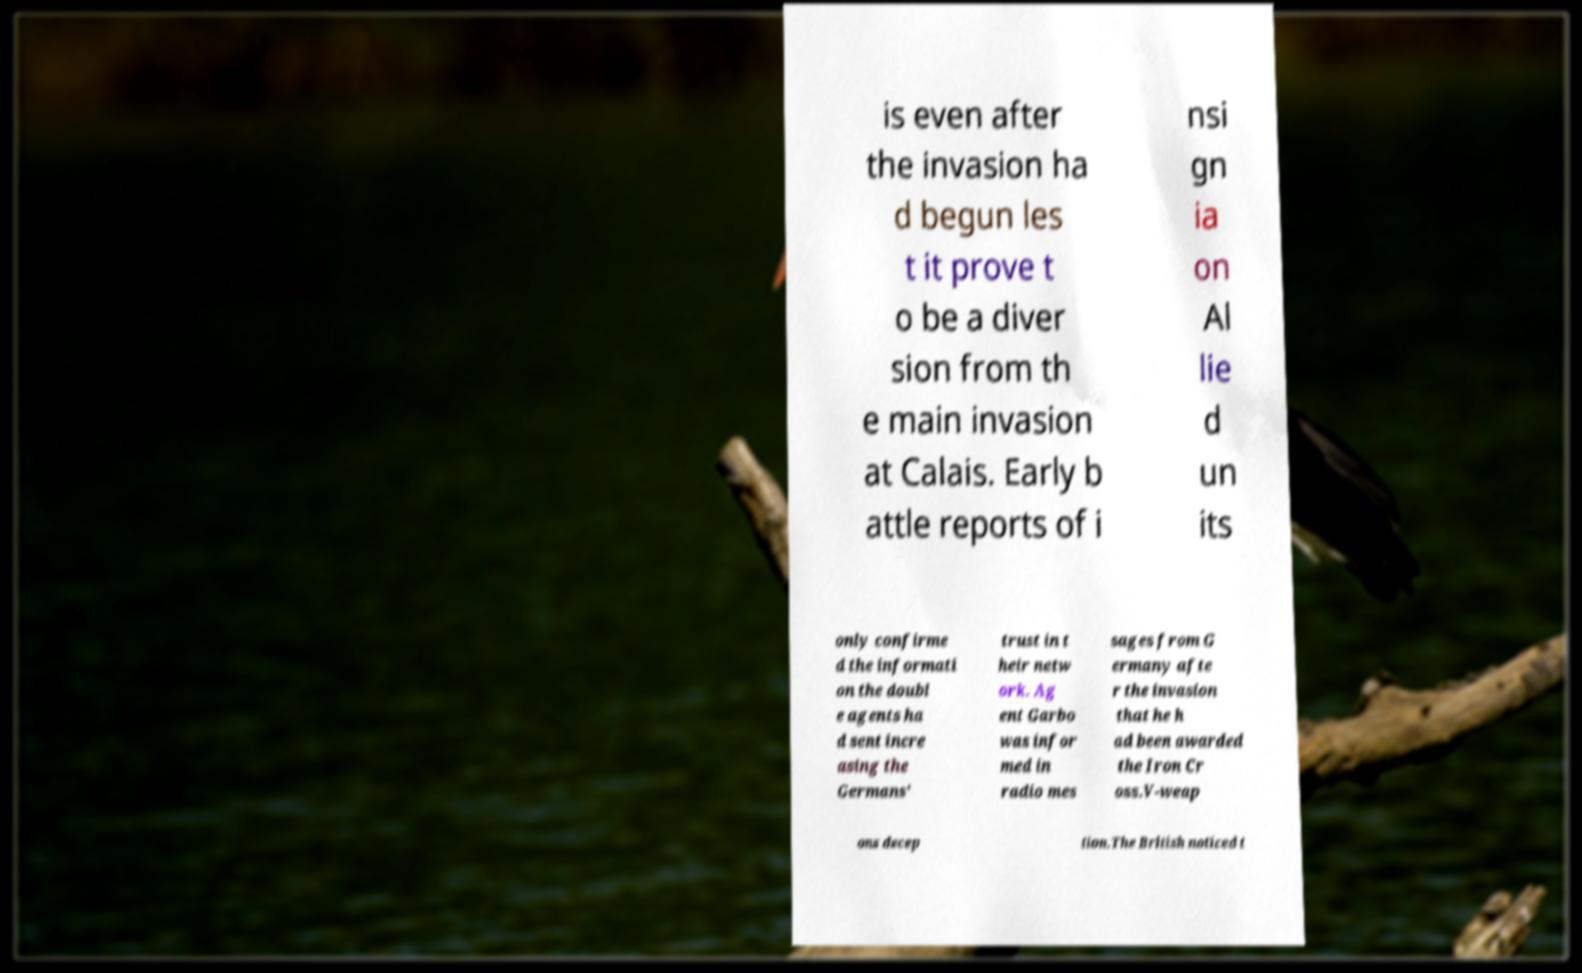Please identify and transcribe the text found in this image. is even after the invasion ha d begun les t it prove t o be a diver sion from th e main invasion at Calais. Early b attle reports of i nsi gn ia on Al lie d un its only confirme d the informati on the doubl e agents ha d sent incre asing the Germans' trust in t heir netw ork. Ag ent Garbo was infor med in radio mes sages from G ermany afte r the invasion that he h ad been awarded the Iron Cr oss.V-weap ons decep tion.The British noticed t 